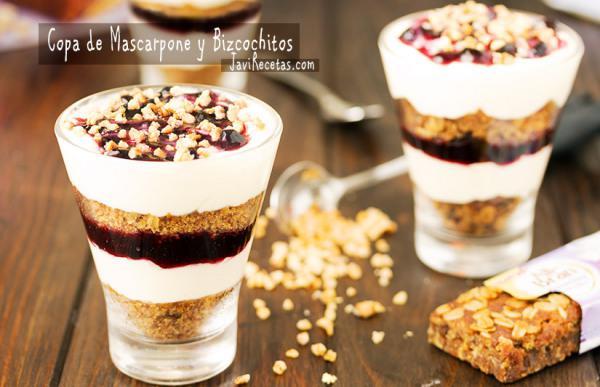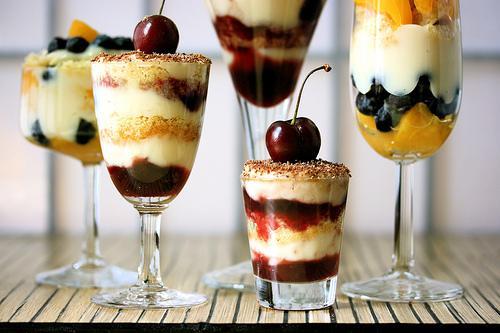The first image is the image on the left, the second image is the image on the right. Considering the images on both sides, is "There are treats in the right image that are topped with cherries, but none in the left image." valid? Answer yes or no. Yes. 